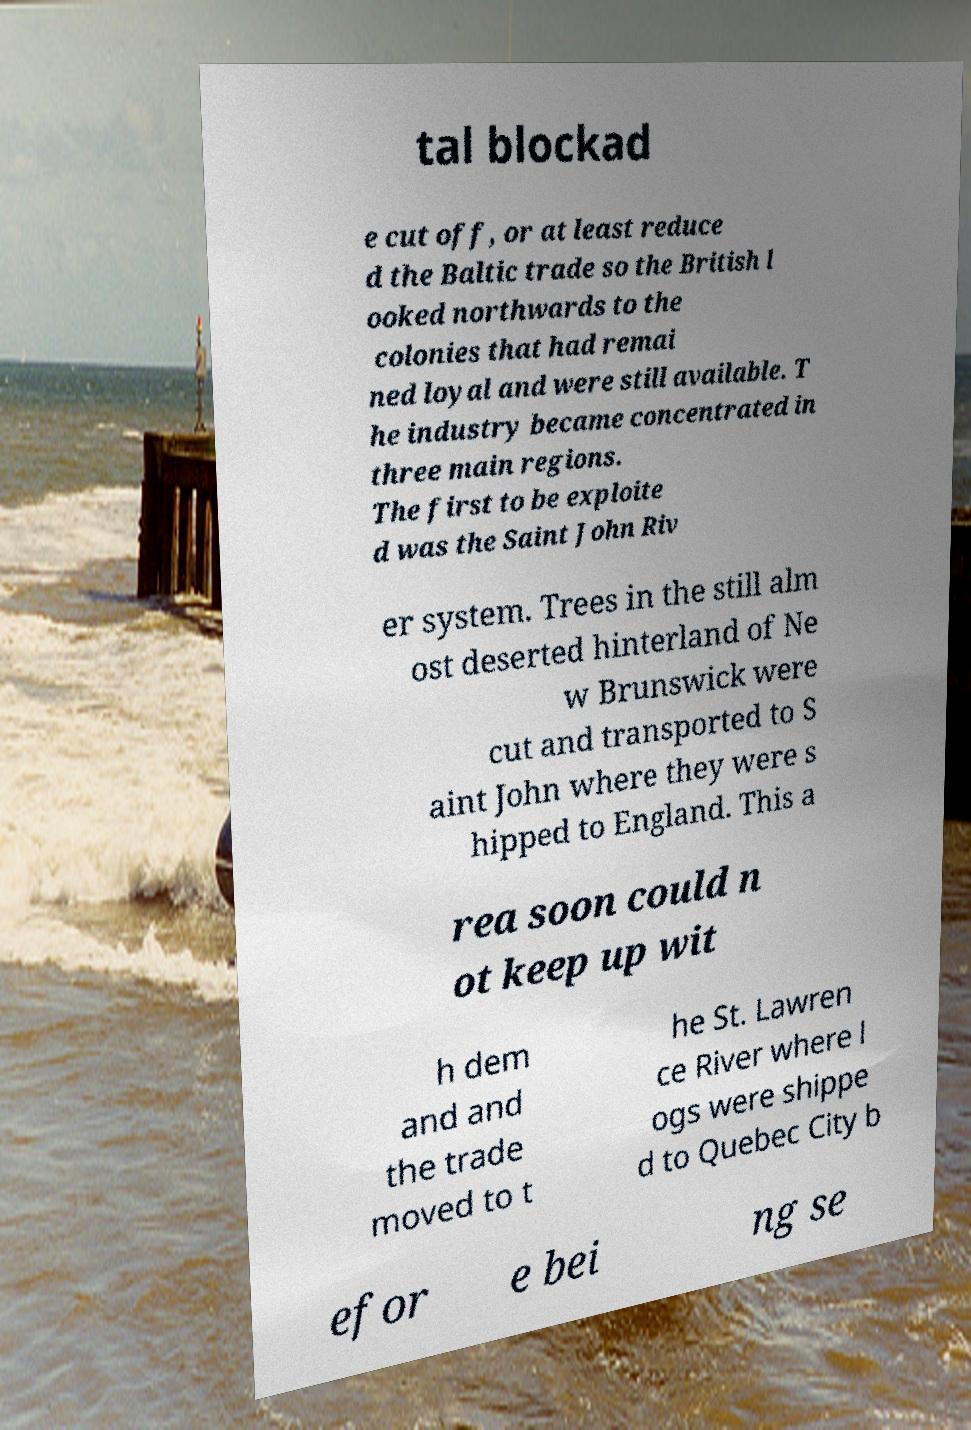For documentation purposes, I need the text within this image transcribed. Could you provide that? tal blockad e cut off, or at least reduce d the Baltic trade so the British l ooked northwards to the colonies that had remai ned loyal and were still available. T he industry became concentrated in three main regions. The first to be exploite d was the Saint John Riv er system. Trees in the still alm ost deserted hinterland of Ne w Brunswick were cut and transported to S aint John where they were s hipped to England. This a rea soon could n ot keep up wit h dem and and the trade moved to t he St. Lawren ce River where l ogs were shippe d to Quebec City b efor e bei ng se 